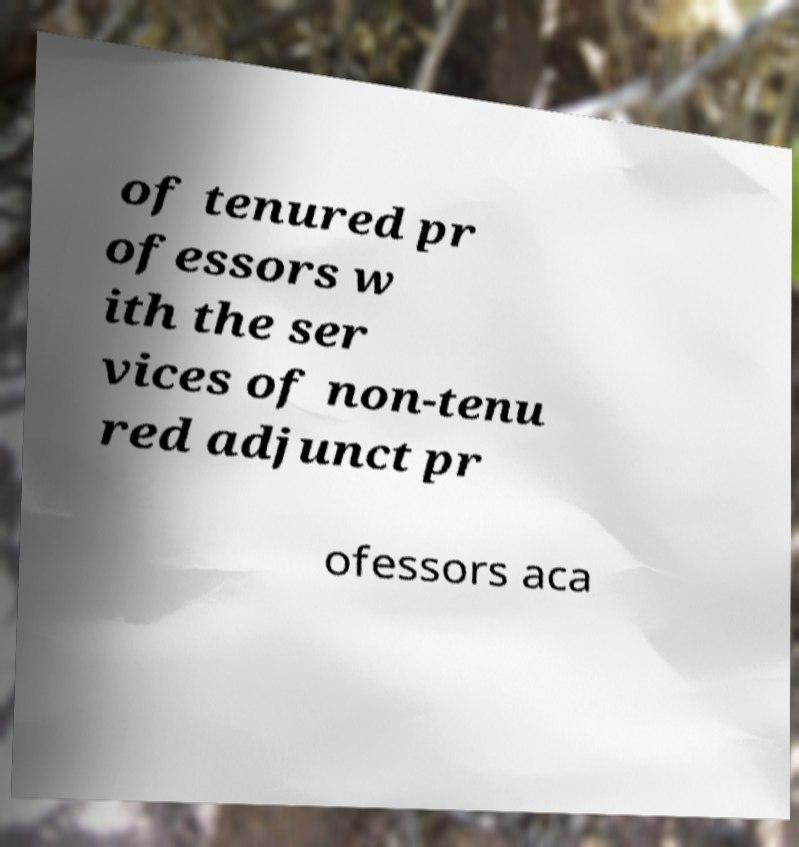I need the written content from this picture converted into text. Can you do that? of tenured pr ofessors w ith the ser vices of non-tenu red adjunct pr ofessors aca 